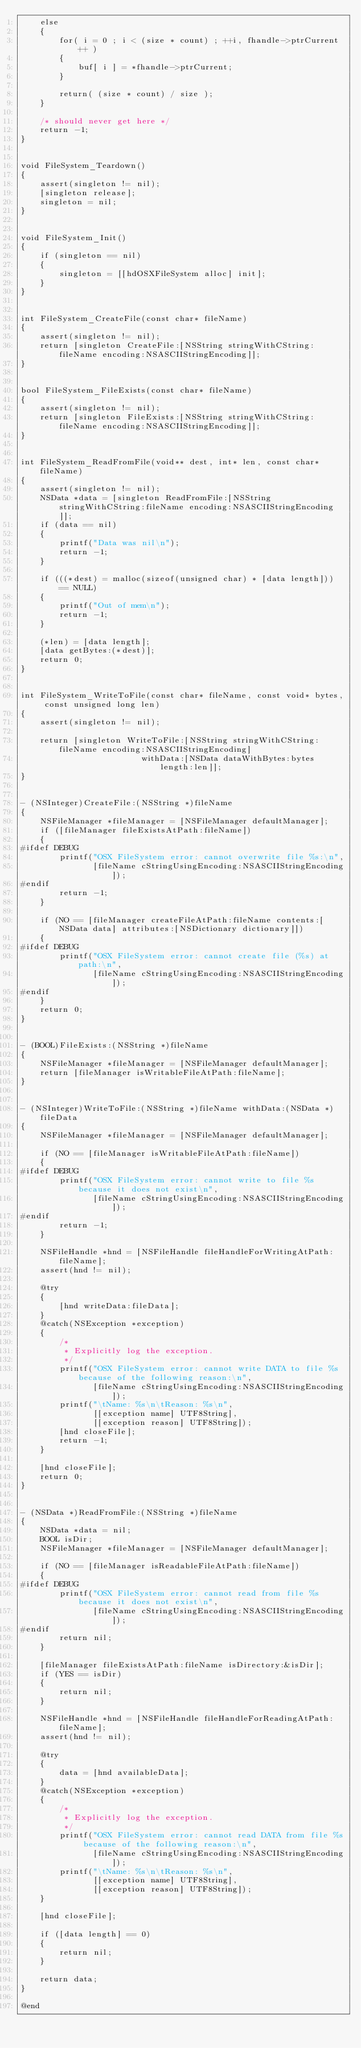<code> <loc_0><loc_0><loc_500><loc_500><_ObjectiveC_>    else
    {
        for( i = 0 ; i < (size * count) ; ++i, fhandle->ptrCurrent++ )
        {
            buf[ i ] = *fhandle->ptrCurrent;
        }

        return( (size * count) / size );
    }

    /* should never get here */
    return -1;
}


void FileSystem_Teardown()
{
    assert(singleton != nil);
    [singleton release];
    singleton = nil;
}


void FileSystem_Init()
{
    if (singleton == nil)
    {
        singleton = [[hdOSXFileSystem alloc] init];
    }
}


int FileSystem_CreateFile(const char* fileName)
{
    assert(singleton != nil);
    return [singleton CreateFile:[NSString stringWithCString:fileName encoding:NSASCIIStringEncoding]];
}


bool FileSystem_FileExists(const char* fileName)
{
    assert(singleton != nil);
    return [singleton FileExists:[NSString stringWithCString:fileName encoding:NSASCIIStringEncoding]];
}


int FileSystem_ReadFromFile(void** dest, int* len, const char* fileName)
{
    assert(singleton != nil);
    NSData *data = [singleton ReadFromFile:[NSString stringWithCString:fileName encoding:NSASCIIStringEncoding]];
    if (data == nil)
    {
        printf("Data was nil\n");
        return -1;
    }

    if (((*dest) = malloc(sizeof(unsigned char) * [data length])) == NULL)
    {
        printf("Out of mem\n");
        return -1;
    }

    (*len) = [data length];
    [data getBytes:(*dest)];
    return 0;
}


int FileSystem_WriteToFile(const char* fileName, const void* bytes, const unsigned long len)
{
    assert(singleton != nil);

    return [singleton WriteToFile:[NSString stringWithCString:fileName encoding:NSASCIIStringEncoding]
                         withData:[NSData dataWithBytes:bytes length:len]];
}


- (NSInteger)CreateFile:(NSString *)fileName
{
    NSFileManager *fileManager = [NSFileManager defaultManager];
    if ([fileManager fileExistsAtPath:fileName])
    {
#ifdef DEBUG
        printf("OSX FileSystem error: cannot overwrite file %s:\n",
               [fileName cStringUsingEncoding:NSASCIIStringEncoding]);
#endif
        return -1;
    }

    if (NO == [fileManager createFileAtPath:fileName contents:[NSData data] attributes:[NSDictionary dictionary]])
    {
#ifdef DEBUG
        printf("OSX FileSystem error: cannot create file (%s) at path:\n",
               [fileName cStringUsingEncoding:NSASCIIStringEncoding]);
#endif
    }
    return 0;
}


- (BOOL)FileExists:(NSString *)fileName
{
    NSFileManager *fileManager = [NSFileManager defaultManager];
    return [fileManager isWritableFileAtPath:fileName];
}


- (NSInteger)WriteToFile:(NSString *)fileName withData:(NSData *)fileData
{
    NSFileManager *fileManager = [NSFileManager defaultManager];

    if (NO == [fileManager isWritableFileAtPath:fileName])
    {
#ifdef DEBUG
        printf("OSX FileSystem error: cannot write to file %s because it does not exist\n",
               [fileName cStringUsingEncoding:NSASCIIStringEncoding]);
#endif
        return -1;
    }

    NSFileHandle *hnd = [NSFileHandle fileHandleForWritingAtPath:fileName];
    assert(hnd != nil);

    @try
    { 
        [hnd writeData:fileData];
    } 
    @catch(NSException *exception)
    {
        /*
         * Explicitly log the exception.
         */
        printf("OSX FileSystem error: cannot write DATA to file %s because of the following reason:\n", 
               [fileName cStringUsingEncoding:NSASCIIStringEncoding]);
        printf("\tName: %s\n\tReason: %s\n",
               [[exception name] UTF8String],
               [[exception reason] UTF8String]);
        [hnd closeFile];
        return -1;
    }
    
    [hnd closeFile];
    return 0;
}


- (NSData *)ReadFromFile:(NSString *)fileName
{
    NSData *data = nil;
    BOOL isDir;
    NSFileManager *fileManager = [NSFileManager defaultManager];
    
    if (NO == [fileManager isReadableFileAtPath:fileName])
    {
#ifdef DEBUG
        printf("OSX FileSystem error: cannot read from file %s because it does not exist\n", 
               [fileName cStringUsingEncoding:NSASCIIStringEncoding]);
#endif
        return nil;
    }
    
    [fileManager fileExistsAtPath:fileName isDirectory:&isDir];
    if (YES == isDir)
    {
        return nil;
    }
    
    NSFileHandle *hnd = [NSFileHandle fileHandleForReadingAtPath:fileName];
    assert(hnd != nil);
    
    @try
    { 
        data = [hnd availableData];
    } 
    @catch(NSException *exception)
    {
        /*
         * Explicitly log the exception.
         */
        printf("OSX FileSystem error: cannot read DATA from file %s because of the following reason:\n", 
               [fileName cStringUsingEncoding:NSASCIIStringEncoding]);
        printf("\tName: %s\n\tReason: %s\n",
               [[exception name] UTF8String],
               [[exception reason] UTF8String]);
    }
    
    [hnd closeFile];
    
    if ([data length] == 0)
    {
        return nil;
    }
    
    return data;
}

@end
</code> 